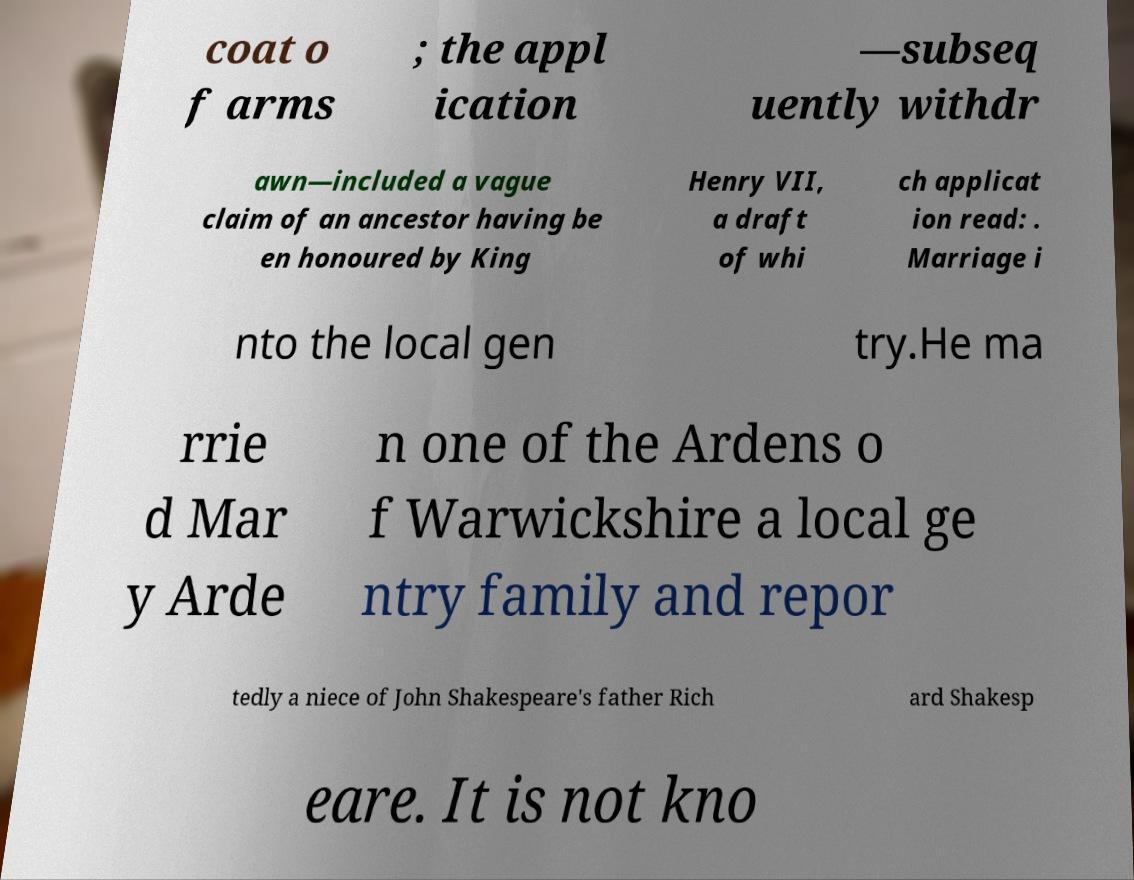Could you assist in decoding the text presented in this image and type it out clearly? coat o f arms ; the appl ication —subseq uently withdr awn—included a vague claim of an ancestor having be en honoured by King Henry VII, a draft of whi ch applicat ion read: . Marriage i nto the local gen try.He ma rrie d Mar y Arde n one of the Ardens o f Warwickshire a local ge ntry family and repor tedly a niece of John Shakespeare's father Rich ard Shakesp eare. It is not kno 